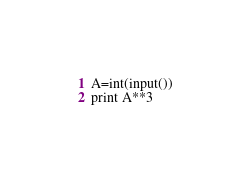Convert code to text. <code><loc_0><loc_0><loc_500><loc_500><_Python_>A=int(input())
print A**3</code> 